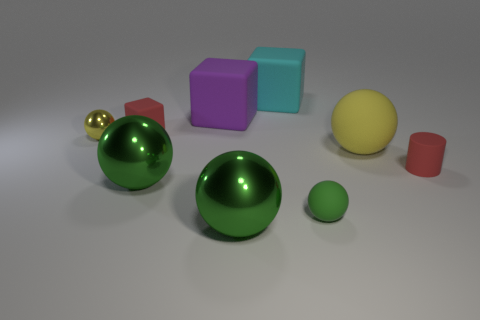Is there anything else of the same color as the cylinder?
Provide a succinct answer. Yes. The small ball that is in front of the yellow sphere that is in front of the yellow thing left of the yellow matte sphere is made of what material?
Offer a very short reply. Rubber. How many metal things are yellow cylinders or tiny objects?
Keep it short and to the point. 1. What number of cyan objects are big matte balls or shiny balls?
Give a very brief answer. 0. There is a big thing right of the big cyan block; does it have the same color as the small rubber block?
Your response must be concise. No. Are the tiny green object and the big purple object made of the same material?
Make the answer very short. Yes. Is the number of tiny metallic balls to the right of the red cube the same as the number of large spheres that are right of the purple matte cube?
Provide a succinct answer. No. What material is the tiny yellow object that is the same shape as the tiny green matte thing?
Provide a succinct answer. Metal. What is the shape of the small red object behind the rubber ball behind the tiny matte thing to the right of the yellow rubber sphere?
Offer a terse response. Cube. Are there more tiny spheres to the right of the red cube than large cyan matte blocks?
Ensure brevity in your answer.  No. 